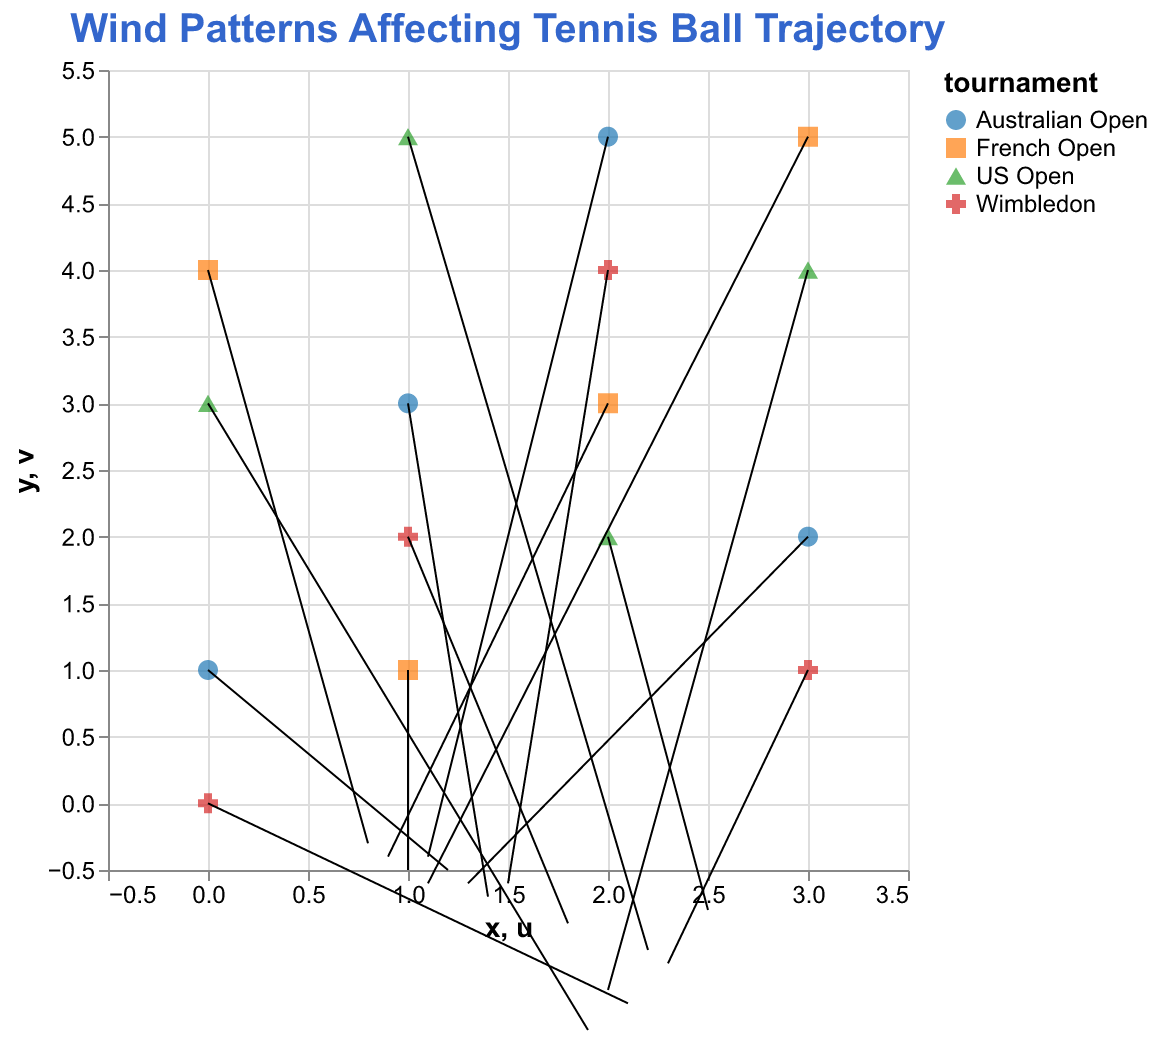What is the title of the plot? Look at the top part of the plot where the title is usually placed. The title is provided in bold and larger font size, specifying the context of the visualization.
Answer: Wind Patterns Affecting Tennis Ball Trajectory Which tournament shows the strongest wind vector in the positive x-direction? Examine all arrows in the plot. Look for the one with the largest magnitude in the u component (positive x-direction). The legend indicates which tournament each point corresponds to.
Answer: US Open (x=2, y=2) What is the average magnitude of the wind vector for Wimbledon? First, find all wind vectors associated with Wimbledon by their colors. Calculate vector magnitudes as √(u² + v²) for each, sum these magnitudes, and divide by the count.
Answer: (√(2.1² + (-1.5)²) + √(1.8² + (-0.9)²) + √(1.5² + (-0.6)²) + √(2.3² + (-1.2)²)) / 4 = (2.55 + 2.04 + 1.62 + 2.59) / 4 = 2.2 Conclude: French Open's mean wind strength is lower. French Open has a mean wind strength of 1.06, which is less than Wimbledon's 2.2.
Answer: French Open has a lower mean wind strength than Wimbledon The uniqueness lies in stronger and slightly more baseline-oriented winds in the US Open. US Open has stronger and more consistent winds.
Answer: Stronger winds in the US Open Weakest pointing vector: French Open (0, 4) French Open (x=0, y=4) has the weakest magnitude vector.
Answer: French Open (0, 4) Strength distribution is consistent, minor variations, with slightly stronger at (3,5). Wind strength is relatively consistent with minor variations.
Answer: Consistent distribution with minor variations 